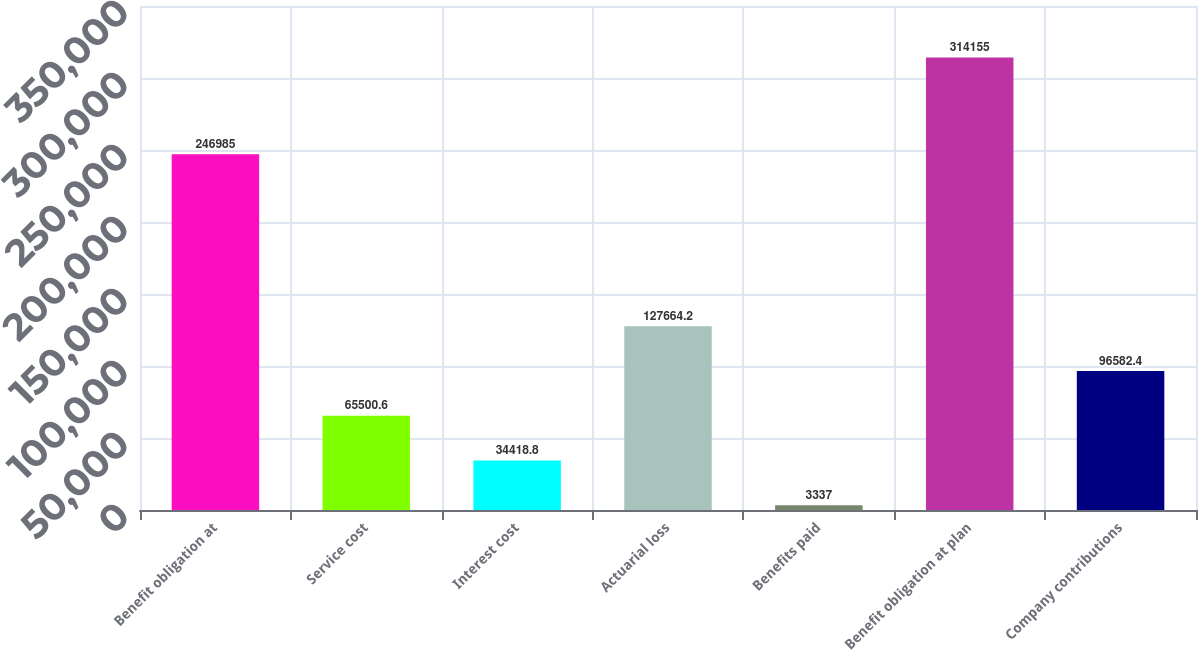Convert chart to OTSL. <chart><loc_0><loc_0><loc_500><loc_500><bar_chart><fcel>Benefit obligation at<fcel>Service cost<fcel>Interest cost<fcel>Actuarial loss<fcel>Benefits paid<fcel>Benefit obligation at plan<fcel>Company contributions<nl><fcel>246985<fcel>65500.6<fcel>34418.8<fcel>127664<fcel>3337<fcel>314155<fcel>96582.4<nl></chart> 